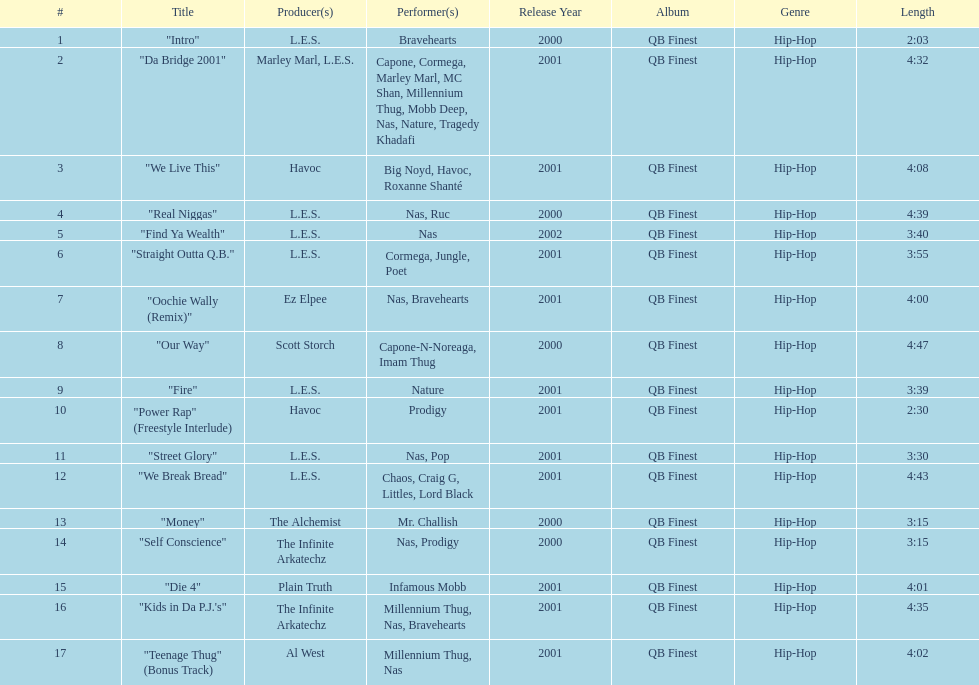Can you give me this table as a dict? {'header': ['#', 'Title', 'Producer(s)', 'Performer(s)', 'Release Year', 'Album', 'Genre', 'Length'], 'rows': [['1', '"Intro"', 'L.E.S.', 'Bravehearts', '2000', 'QB Finest', 'Hip-Hop', '2:03'], ['2', '"Da Bridge 2001"', 'Marley Marl, L.E.S.', 'Capone, Cormega, Marley Marl, MC Shan, Millennium Thug, Mobb Deep, Nas, Nature, Tragedy Khadafi', '2001', 'QB Finest', 'Hip-Hop', '4:32'], ['3', '"We Live This"', 'Havoc', 'Big Noyd, Havoc, Roxanne Shanté', '2001', 'QB Finest', 'Hip-Hop', '4:08'], ['4', '"Real Niggas"', 'L.E.S.', 'Nas, Ruc', '2000', 'QB Finest', 'Hip-Hop', '4:39'], ['5', '"Find Ya Wealth"', 'L.E.S.', 'Nas', '2002', 'QB Finest', 'Hip-Hop', '3:40'], ['6', '"Straight Outta Q.B."', 'L.E.S.', 'Cormega, Jungle, Poet', '2001', 'QB Finest', 'Hip-Hop', '3:55'], ['7', '"Oochie Wally (Remix)"', 'Ez Elpee', 'Nas, Bravehearts', '2001', 'QB Finest', 'Hip-Hop', '4:00'], ['8', '"Our Way"', 'Scott Storch', 'Capone-N-Noreaga, Imam Thug', '2000', 'QB Finest', 'Hip-Hop', '4:47'], ['9', '"Fire"', 'L.E.S.', 'Nature', '2001', 'QB Finest', 'Hip-Hop', '3:39'], ['10', '"Power Rap" (Freestyle Interlude)', 'Havoc', 'Prodigy', '2001', 'QB Finest', 'Hip-Hop', '2:30'], ['11', '"Street Glory"', 'L.E.S.', 'Nas, Pop', '2001', 'QB Finest', 'Hip-Hop', '3:30'], ['12', '"We Break Bread"', 'L.E.S.', 'Chaos, Craig G, Littles, Lord Black', '2001', 'QB Finest', 'Hip-Hop', '4:43'], ['13', '"Money"', 'The Alchemist', 'Mr. Challish', '2000', 'QB Finest', 'Hip-Hop', '3:15'], ['14', '"Self Conscience"', 'The Infinite Arkatechz', 'Nas, Prodigy', '2000', 'QB Finest', 'Hip-Hop', '3:15'], ['15', '"Die 4"', 'Plain Truth', 'Infamous Mobb', '2001', 'QB Finest', 'Hip-Hop', '4:01'], ['16', '"Kids in Da P.J.\'s"', 'The Infinite Arkatechz', 'Millennium Thug, Nas, Bravehearts', '2001', 'QB Finest', 'Hip-Hop', '4:35'], ['17', '"Teenage Thug" (Bonus Track)', 'Al West', 'Millennium Thug, Nas', '2001', 'QB Finest', 'Hip-Hop', '4:02']]} Who made the last track on the album? Al West. 